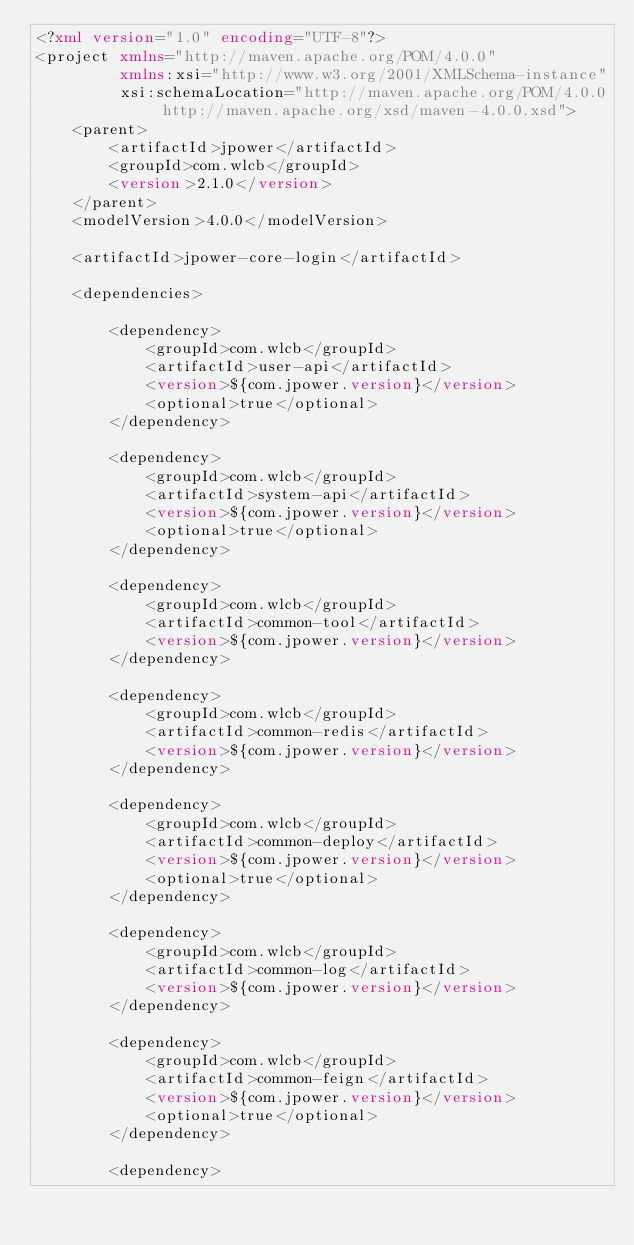<code> <loc_0><loc_0><loc_500><loc_500><_XML_><?xml version="1.0" encoding="UTF-8"?>
<project xmlns="http://maven.apache.org/POM/4.0.0"
         xmlns:xsi="http://www.w3.org/2001/XMLSchema-instance"
         xsi:schemaLocation="http://maven.apache.org/POM/4.0.0 http://maven.apache.org/xsd/maven-4.0.0.xsd">
    <parent>
        <artifactId>jpower</artifactId>
        <groupId>com.wlcb</groupId>
        <version>2.1.0</version>
    </parent>
    <modelVersion>4.0.0</modelVersion>

    <artifactId>jpower-core-login</artifactId>

    <dependencies>

        <dependency>
            <groupId>com.wlcb</groupId>
            <artifactId>user-api</artifactId>
            <version>${com.jpower.version}</version>
            <optional>true</optional>
        </dependency>

        <dependency>
            <groupId>com.wlcb</groupId>
            <artifactId>system-api</artifactId>
            <version>${com.jpower.version}</version>
            <optional>true</optional>
        </dependency>

        <dependency>
            <groupId>com.wlcb</groupId>
            <artifactId>common-tool</artifactId>
            <version>${com.jpower.version}</version>
        </dependency>

        <dependency>
            <groupId>com.wlcb</groupId>
            <artifactId>common-redis</artifactId>
            <version>${com.jpower.version}</version>
        </dependency>

        <dependency>
            <groupId>com.wlcb</groupId>
            <artifactId>common-deploy</artifactId>
            <version>${com.jpower.version}</version>
            <optional>true</optional>
        </dependency>

        <dependency>
            <groupId>com.wlcb</groupId>
            <artifactId>common-log</artifactId>
            <version>${com.jpower.version}</version>
        </dependency>

        <dependency>
            <groupId>com.wlcb</groupId>
            <artifactId>common-feign</artifactId>
            <version>${com.jpower.version}</version>
            <optional>true</optional>
        </dependency>

        <dependency></code> 